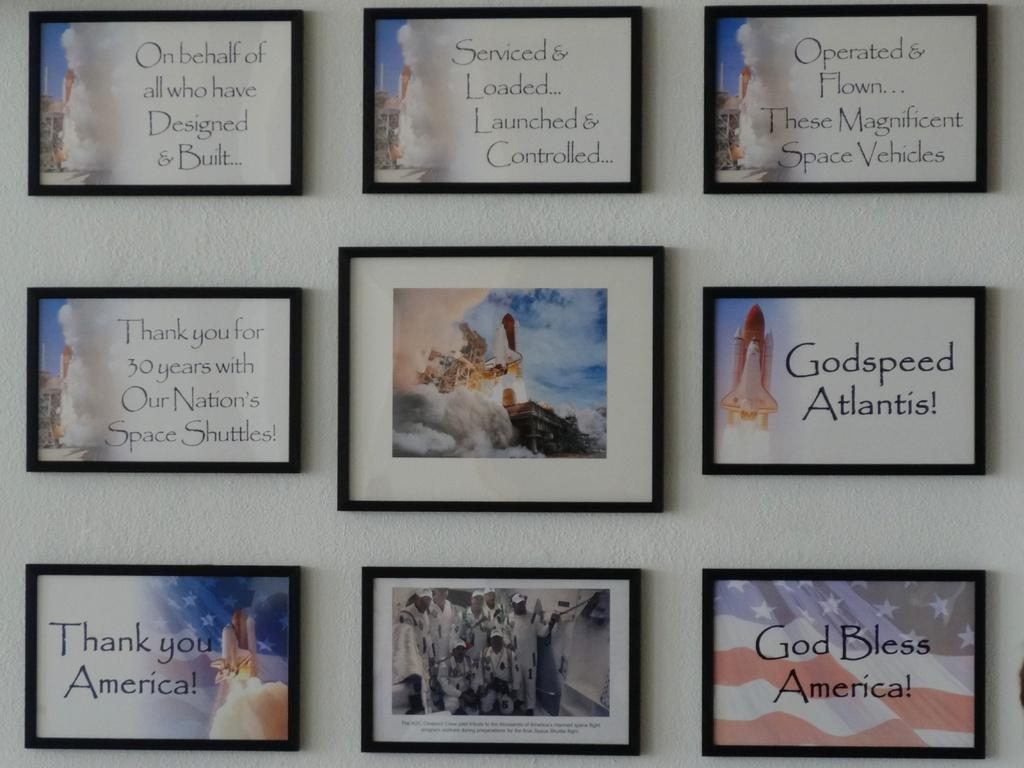What is hanging on the wall in the image? There are photo frames on the wall. What is inside the photo frames? The photo frames contain pictures and text. What type of insect can be seen crawling on the division in the image? There is no division or insect present in the image. 